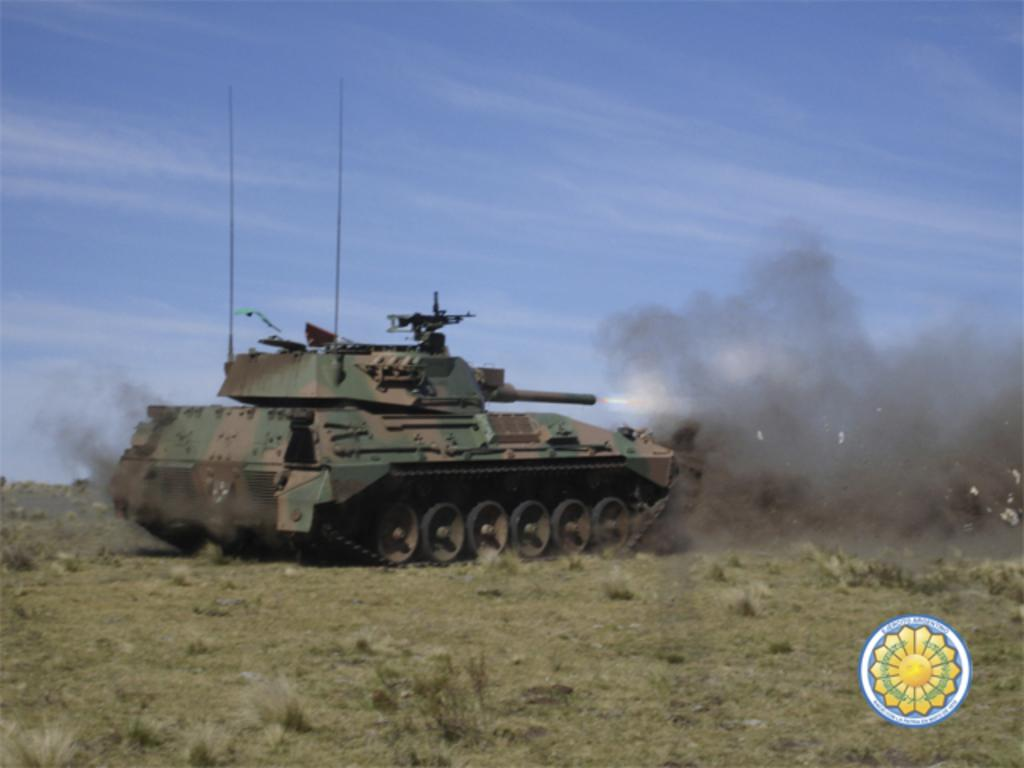What is the main object in the image? There is a tank on the grass in the image. What can be seen in the background of the image? The sky is visible in the background of the image. Is there any additional information about the image itself? Yes, there is a watermark on the image. How many lizards are crawling on the tank in the image? There are no lizards present in the image; it only features a tank on the grass. What type of flesh can be seen on the tank in the image? There is no flesh visible on the tank in the image; it is a military vehicle. 